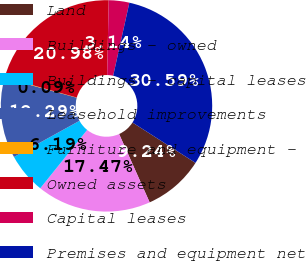Convert chart to OTSL. <chart><loc_0><loc_0><loc_500><loc_500><pie_chart><fcel>Land<fcel>Buildings - owned<fcel>Buildings - capital leases<fcel>Leasehold improvements<fcel>Furniture and equipment -<fcel>Owned assets<fcel>Capital leases<fcel>Premises and equipment net<nl><fcel>9.24%<fcel>17.47%<fcel>6.19%<fcel>12.29%<fcel>0.09%<fcel>20.98%<fcel>3.14%<fcel>30.59%<nl></chart> 